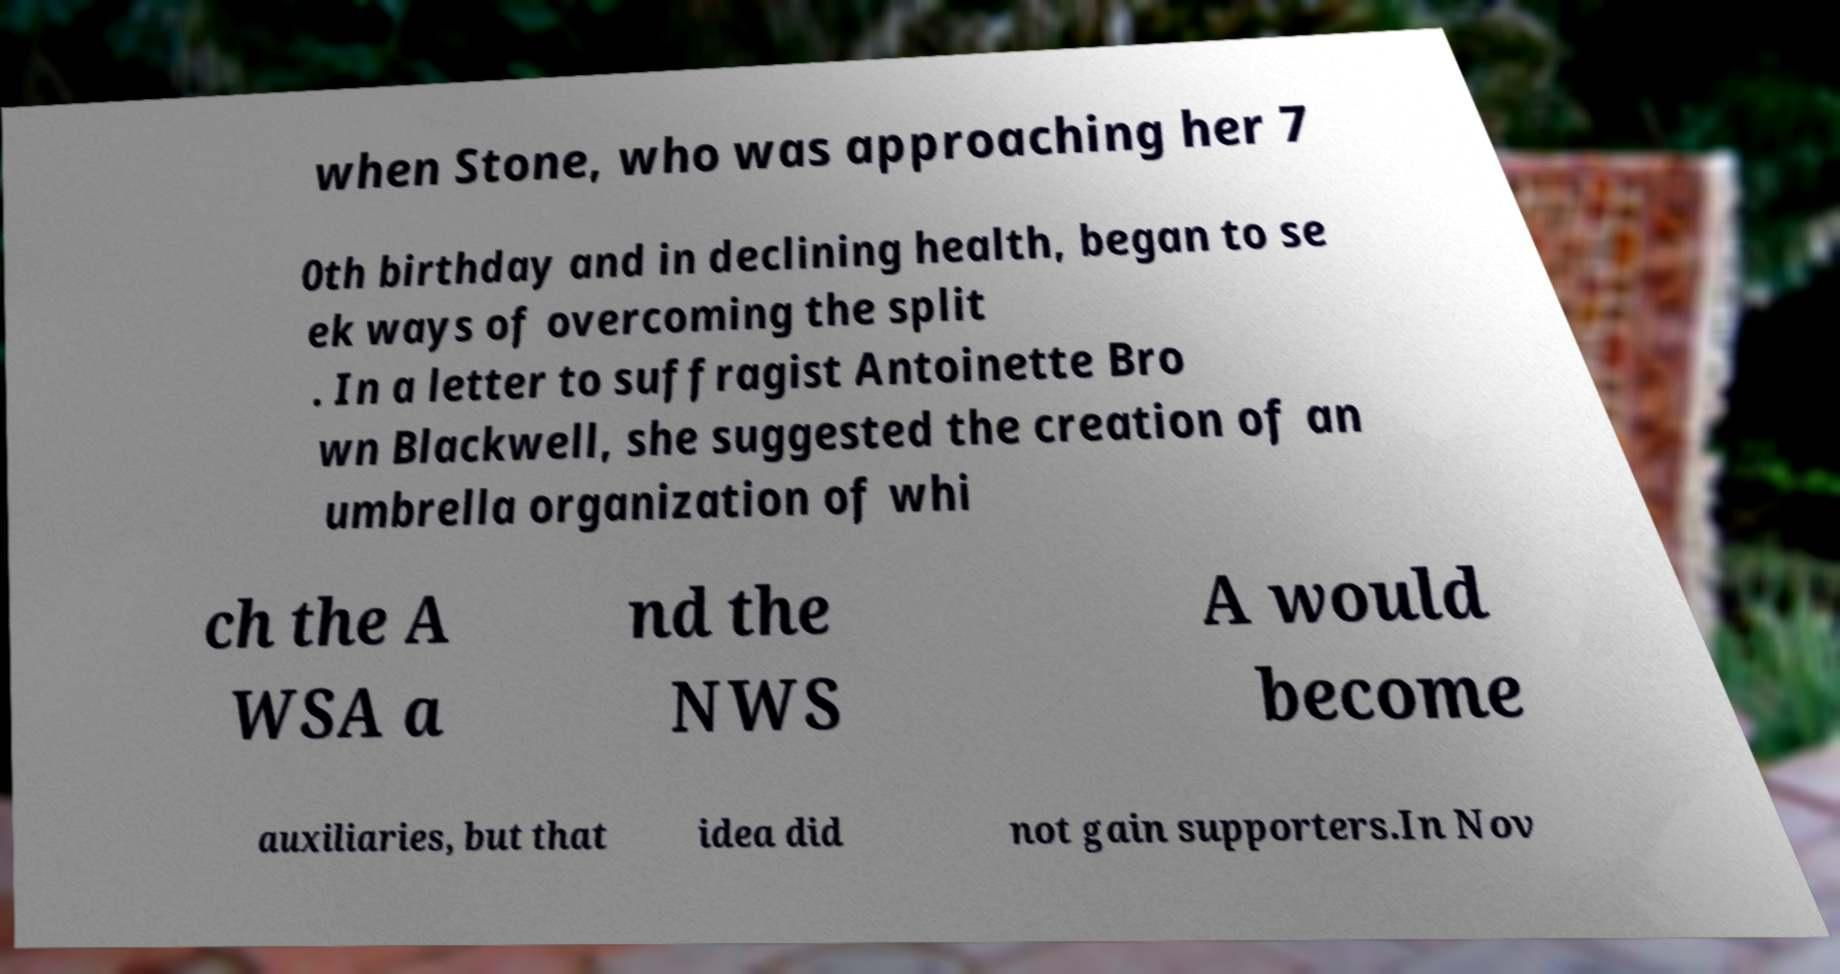I need the written content from this picture converted into text. Can you do that? when Stone, who was approaching her 7 0th birthday and in declining health, began to se ek ways of overcoming the split . In a letter to suffragist Antoinette Bro wn Blackwell, she suggested the creation of an umbrella organization of whi ch the A WSA a nd the NWS A would become auxiliaries, but that idea did not gain supporters.In Nov 